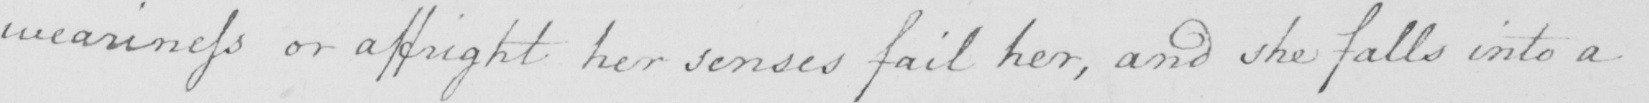Can you read and transcribe this handwriting? weariness or affright her senses fail her , and she falls into a 